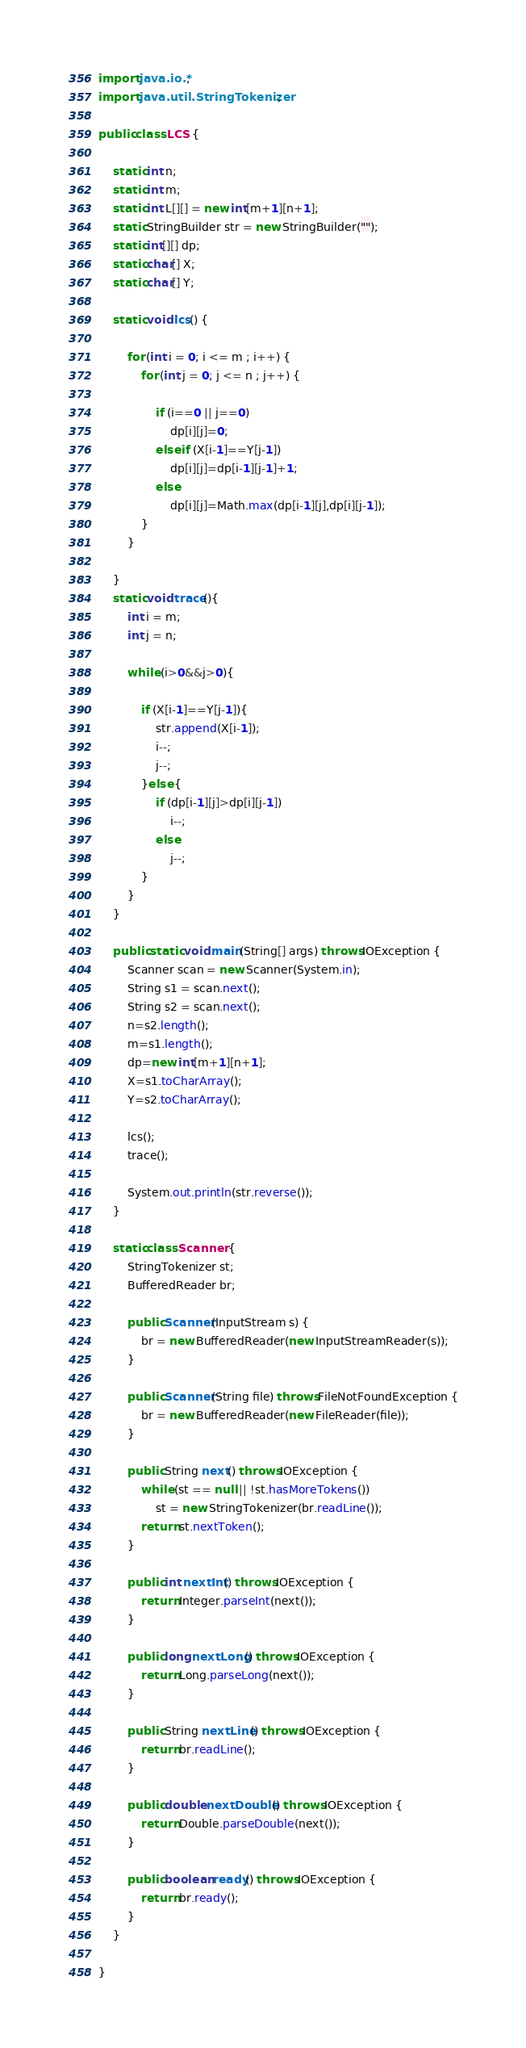Convert code to text. <code><loc_0><loc_0><loc_500><loc_500><_Java_>import java.io.*;
import java.util.StringTokenizer;

public class LCS {

    static int n;
    static int m;
    static int L[][] = new int[m+1][n+1];
    static StringBuilder str = new StringBuilder("");
    static int[][] dp;
    static char[] X;
    static char[] Y;

    static void lcs() {

        for (int i = 0; i <= m ; i++) {
            for (int j = 0; j <= n ; j++) {

                if (i==0 || j==0)
                    dp[i][j]=0;
                else if (X[i-1]==Y[j-1])
                    dp[i][j]=dp[i-1][j-1]+1;
                else
                    dp[i][j]=Math.max(dp[i-1][j],dp[i][j-1]);
            }
        }

    }
    static void trace(){
        int i = m;
        int j = n;

        while (i>0&&j>0){

            if (X[i-1]==Y[j-1]){
                str.append(X[i-1]);
                i--;
                j--;
            }else {
                if (dp[i-1][j]>dp[i][j-1])
                    i--;
                else
                    j--;
            }
        }
    }

    public static void main(String[] args) throws IOException {
        Scanner scan = new Scanner(System.in);
        String s1 = scan.next();
        String s2 = scan.next();
        n=s2.length();
        m=s1.length();
        dp=new int[m+1][n+1];
        X=s1.toCharArray();
        Y=s2.toCharArray();

        lcs();
        trace();

        System.out.println(str.reverse());
    }

    static class Scanner {
        StringTokenizer st;
        BufferedReader br;

        public Scanner(InputStream s) {
            br = new BufferedReader(new InputStreamReader(s));
        }

        public Scanner(String file) throws FileNotFoundException {
            br = new BufferedReader(new FileReader(file));
        }

        public String next() throws IOException {
            while (st == null || !st.hasMoreTokens())
                st = new StringTokenizer(br.readLine());
            return st.nextToken();
        }

        public int nextInt() throws IOException {
            return Integer.parseInt(next());
        }

        public long nextLong() throws IOException {
            return Long.parseLong(next());
        }

        public String nextLine() throws IOException {
            return br.readLine();
        }

        public double nextDouble() throws IOException {
            return Double.parseDouble(next());
        }

        public boolean ready() throws IOException {
            return br.ready();
        }
    }

}

</code> 